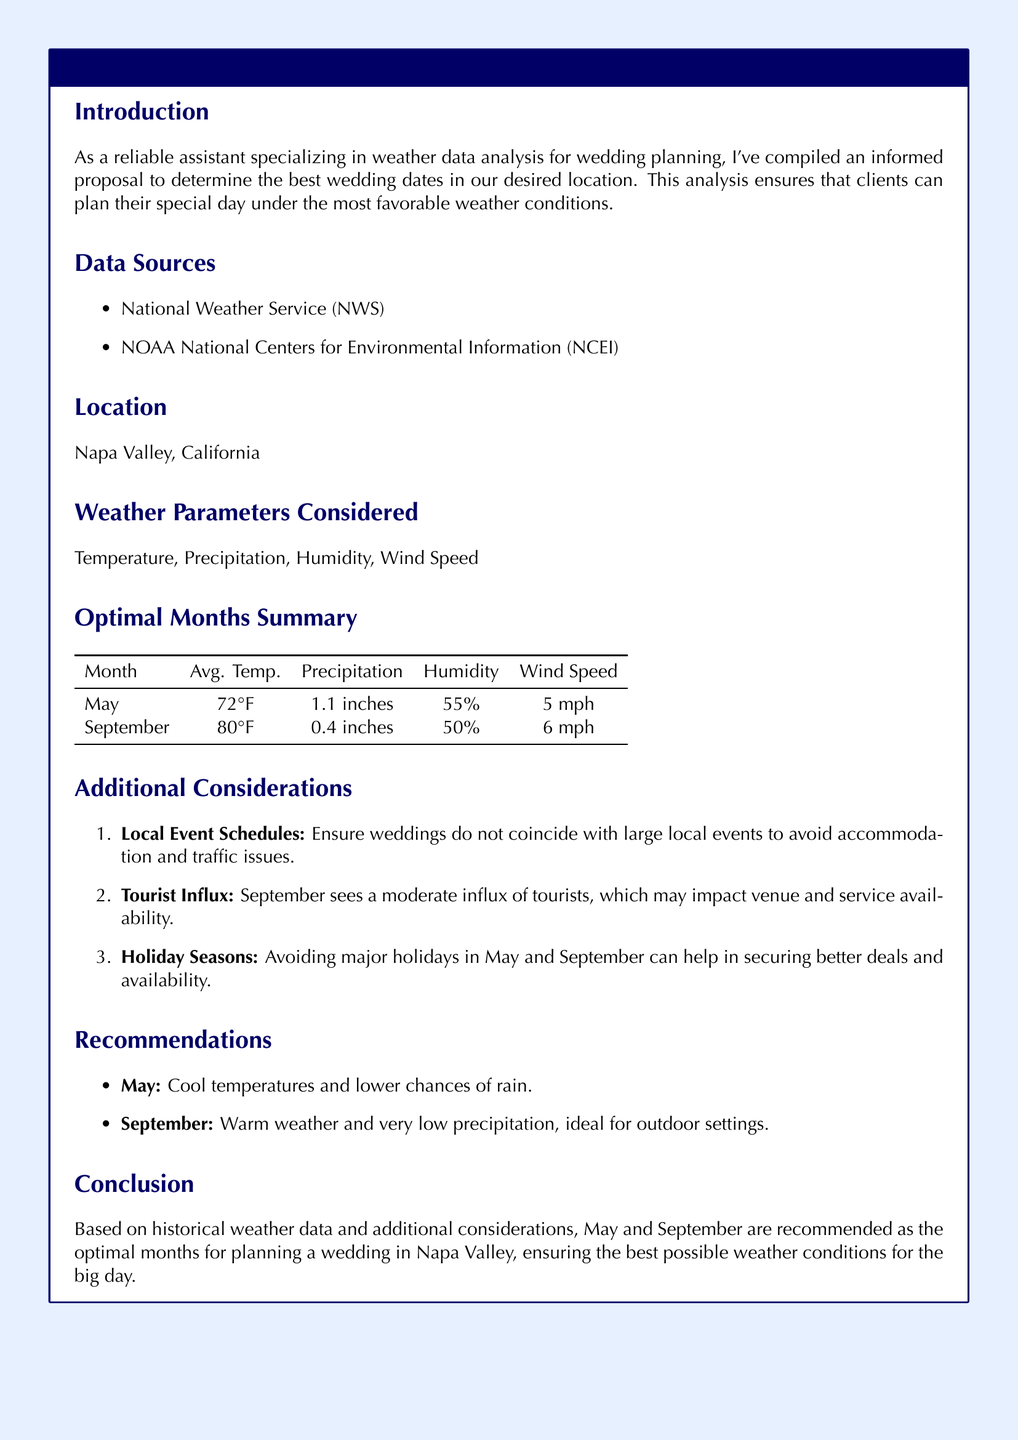What are the two primary data sources mentioned? The proposal lists the National Weather Service (NWS) and NOAA National Centers for Environmental Information (NCEI) as the data sources used for weather analysis.
Answer: NWS, NCEI What is the average temperature in September? The document provides a table summarizing average temperature, precipitation, humidity, and wind speed for May and September. The average temperature for September is listed there.
Answer: 80°F Which month has the lowest precipitation? The optimal months summary table contains details on the average precipitation for both months, indicating which month has lower precipitation.
Answer: September What is one of the additional considerations for wedding dates? The proposal highlights several factors that could affect wedding planning, including local event schedules and tourist influx; it prompts to think about such considerations when choosing dates.
Answer: Local Event Schedules What weather parameter is considered in the analysis? The document lists specific weather parameters that were taken into account in the analysis to determine optimal wedding dates.
Answer: Temperature How does May's average humidity compare to September's? The document includes humidity percentages for May and September in a table that enables comparison between the two months' average humidity levels.
Answer: May is 55%, September is 50% What is the conclusion regarding optimal wedding months? The conclusion summarizes the analysis and recommendations based on historical data, emphasizing which months are suggested for weddings.
Answer: May and September What is the average wind speed in May? The table summarizes various weather parameters for May, including wind speed; this information helps determine conditions suitable for weddings.
Answer: 5 mph 